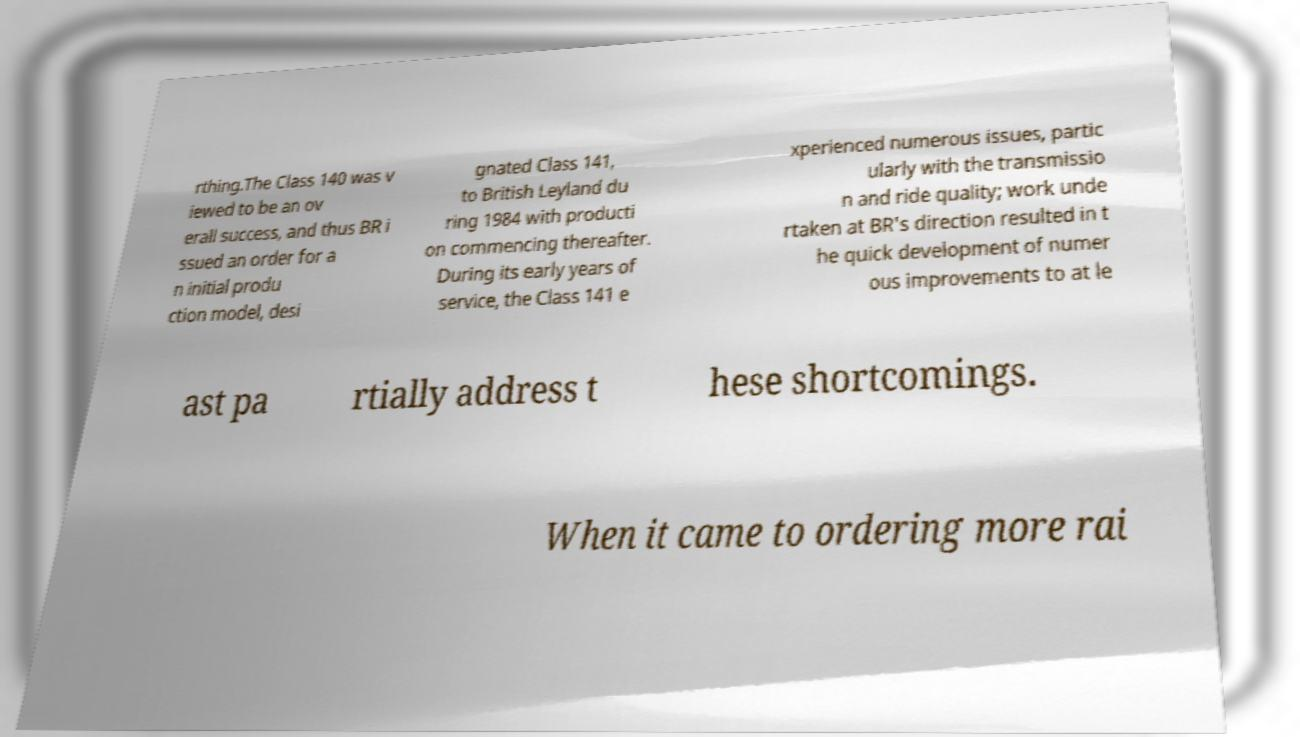Could you extract and type out the text from this image? rthing.The Class 140 was v iewed to be an ov erall success, and thus BR i ssued an order for a n initial produ ction model, desi gnated Class 141, to British Leyland du ring 1984 with producti on commencing thereafter. During its early years of service, the Class 141 e xperienced numerous issues, partic ularly with the transmissio n and ride quality; work unde rtaken at BR's direction resulted in t he quick development of numer ous improvements to at le ast pa rtially address t hese shortcomings. When it came to ordering more rai 